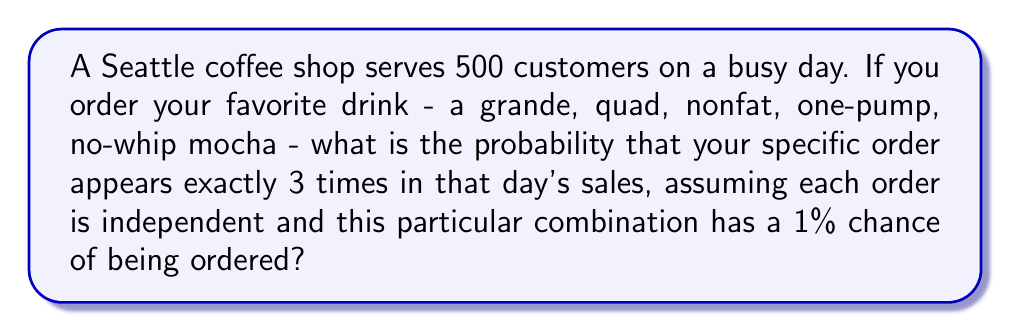Can you solve this math problem? Let's approach this step-by-step using the binomial probability formula:

1) We can model this scenario as a binomial distribution:
   - $n = 500$ (total number of orders)
   - $k = 3$ (we want exactly 3 occurrences)
   - $p = 0.01$ (probability of this specific order)

2) The binomial probability formula is:

   $$ P(X = k) = \binom{n}{k} p^k (1-p)^{n-k} $$

3) Let's calculate each part:

   $\binom{n}{k} = \binom{500}{3} = \frac{500!}{3!(500-3)!} = 20,708,500$

   $p^k = 0.01^3 = 0.000001$

   $(1-p)^{n-k} = 0.99^{497} \approx 0.0067$

4) Now, let's put it all together:

   $$ P(X = 3) = 20,708,500 \times 0.000001 \times 0.0067 \approx 0.1387 $$

5) Therefore, the probability is approximately 0.1387 or 13.87%.
Answer: $0.1387$ or $13.87\%$ 